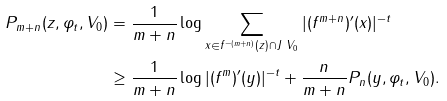<formula> <loc_0><loc_0><loc_500><loc_500>P _ { m + n } ( z , \varphi _ { t } , V _ { 0 } ) & = \frac { 1 } { m + n } \log \sum _ { x \in f ^ { - ( m + n ) } ( z ) \cap J \ V _ { 0 } } | ( f ^ { m + n } ) ^ { \prime } ( x ) | ^ { - t } \\ & \geq \frac { 1 } { m + n } \log | ( f ^ { m } ) ^ { \prime } ( y ) | ^ { - t } + \frac { n } { m + n } P _ { n } ( y , \varphi _ { t } , V _ { 0 } ) .</formula> 